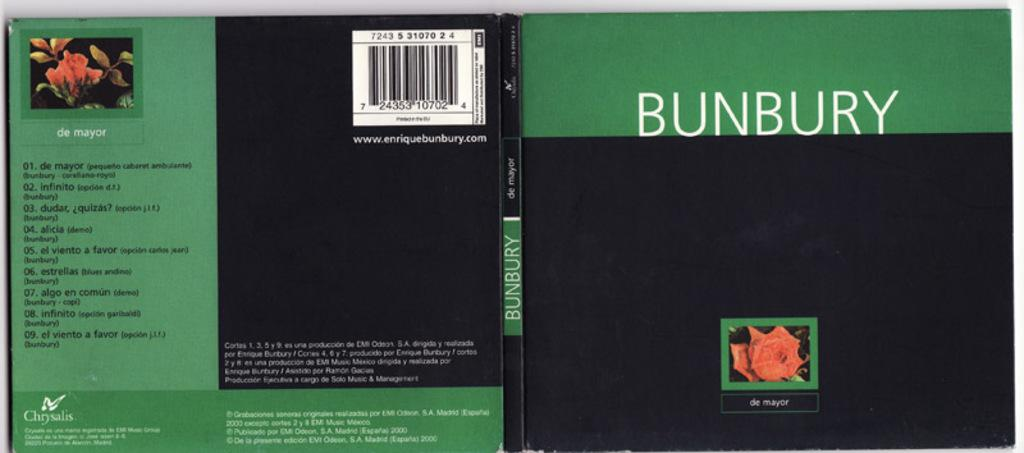<image>
Render a clear and concise summary of the photo. A book with BUNBURY written on the spine. 